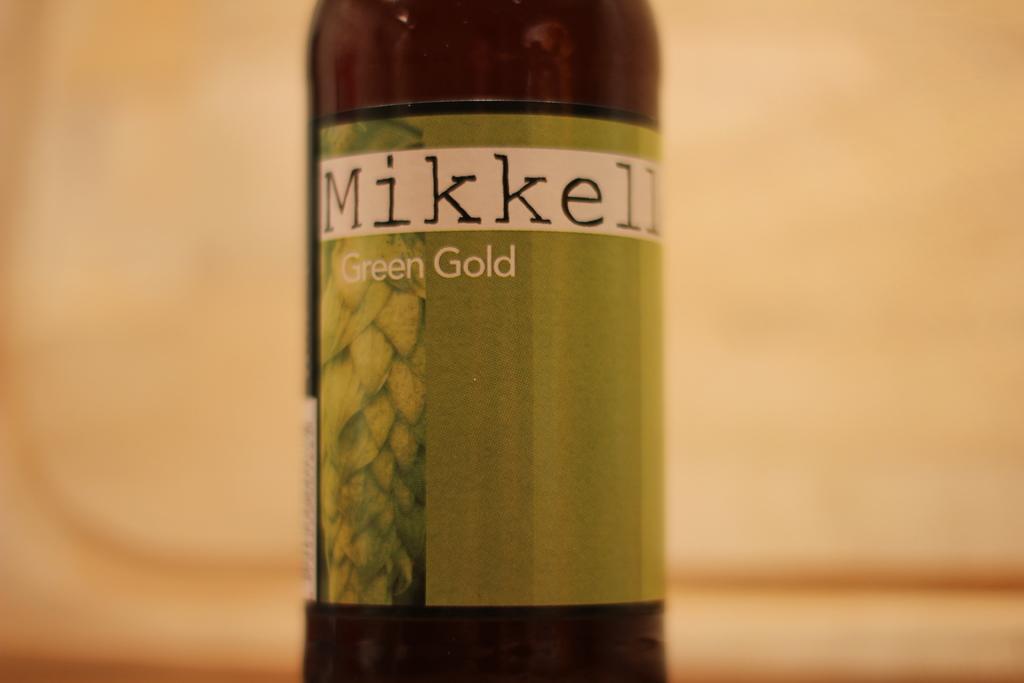Please provide a concise description of this image. In this image we can see a bottle. 